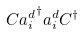Convert formula to latex. <formula><loc_0><loc_0><loc_500><loc_500>C { a _ { i } ^ { d } } ^ { \dagger } a _ { i } ^ { d } C ^ { \dagger }</formula> 